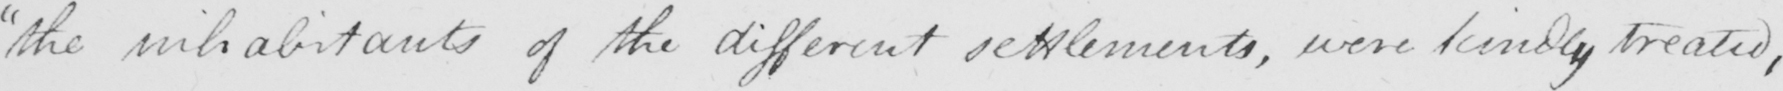Can you tell me what this handwritten text says? "the inhabitants of the different settlements, were kindly treated, 